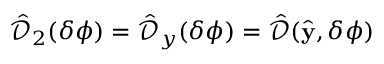Convert formula to latex. <formula><loc_0><loc_0><loc_500><loc_500>\hat { \mathcal { D } } _ { 2 } ( \delta \phi ) = \hat { \mathcal { D } } _ { y } ( \delta \phi ) = \hat { \mathcal { D } } ( \hat { y } , \delta \phi )</formula> 